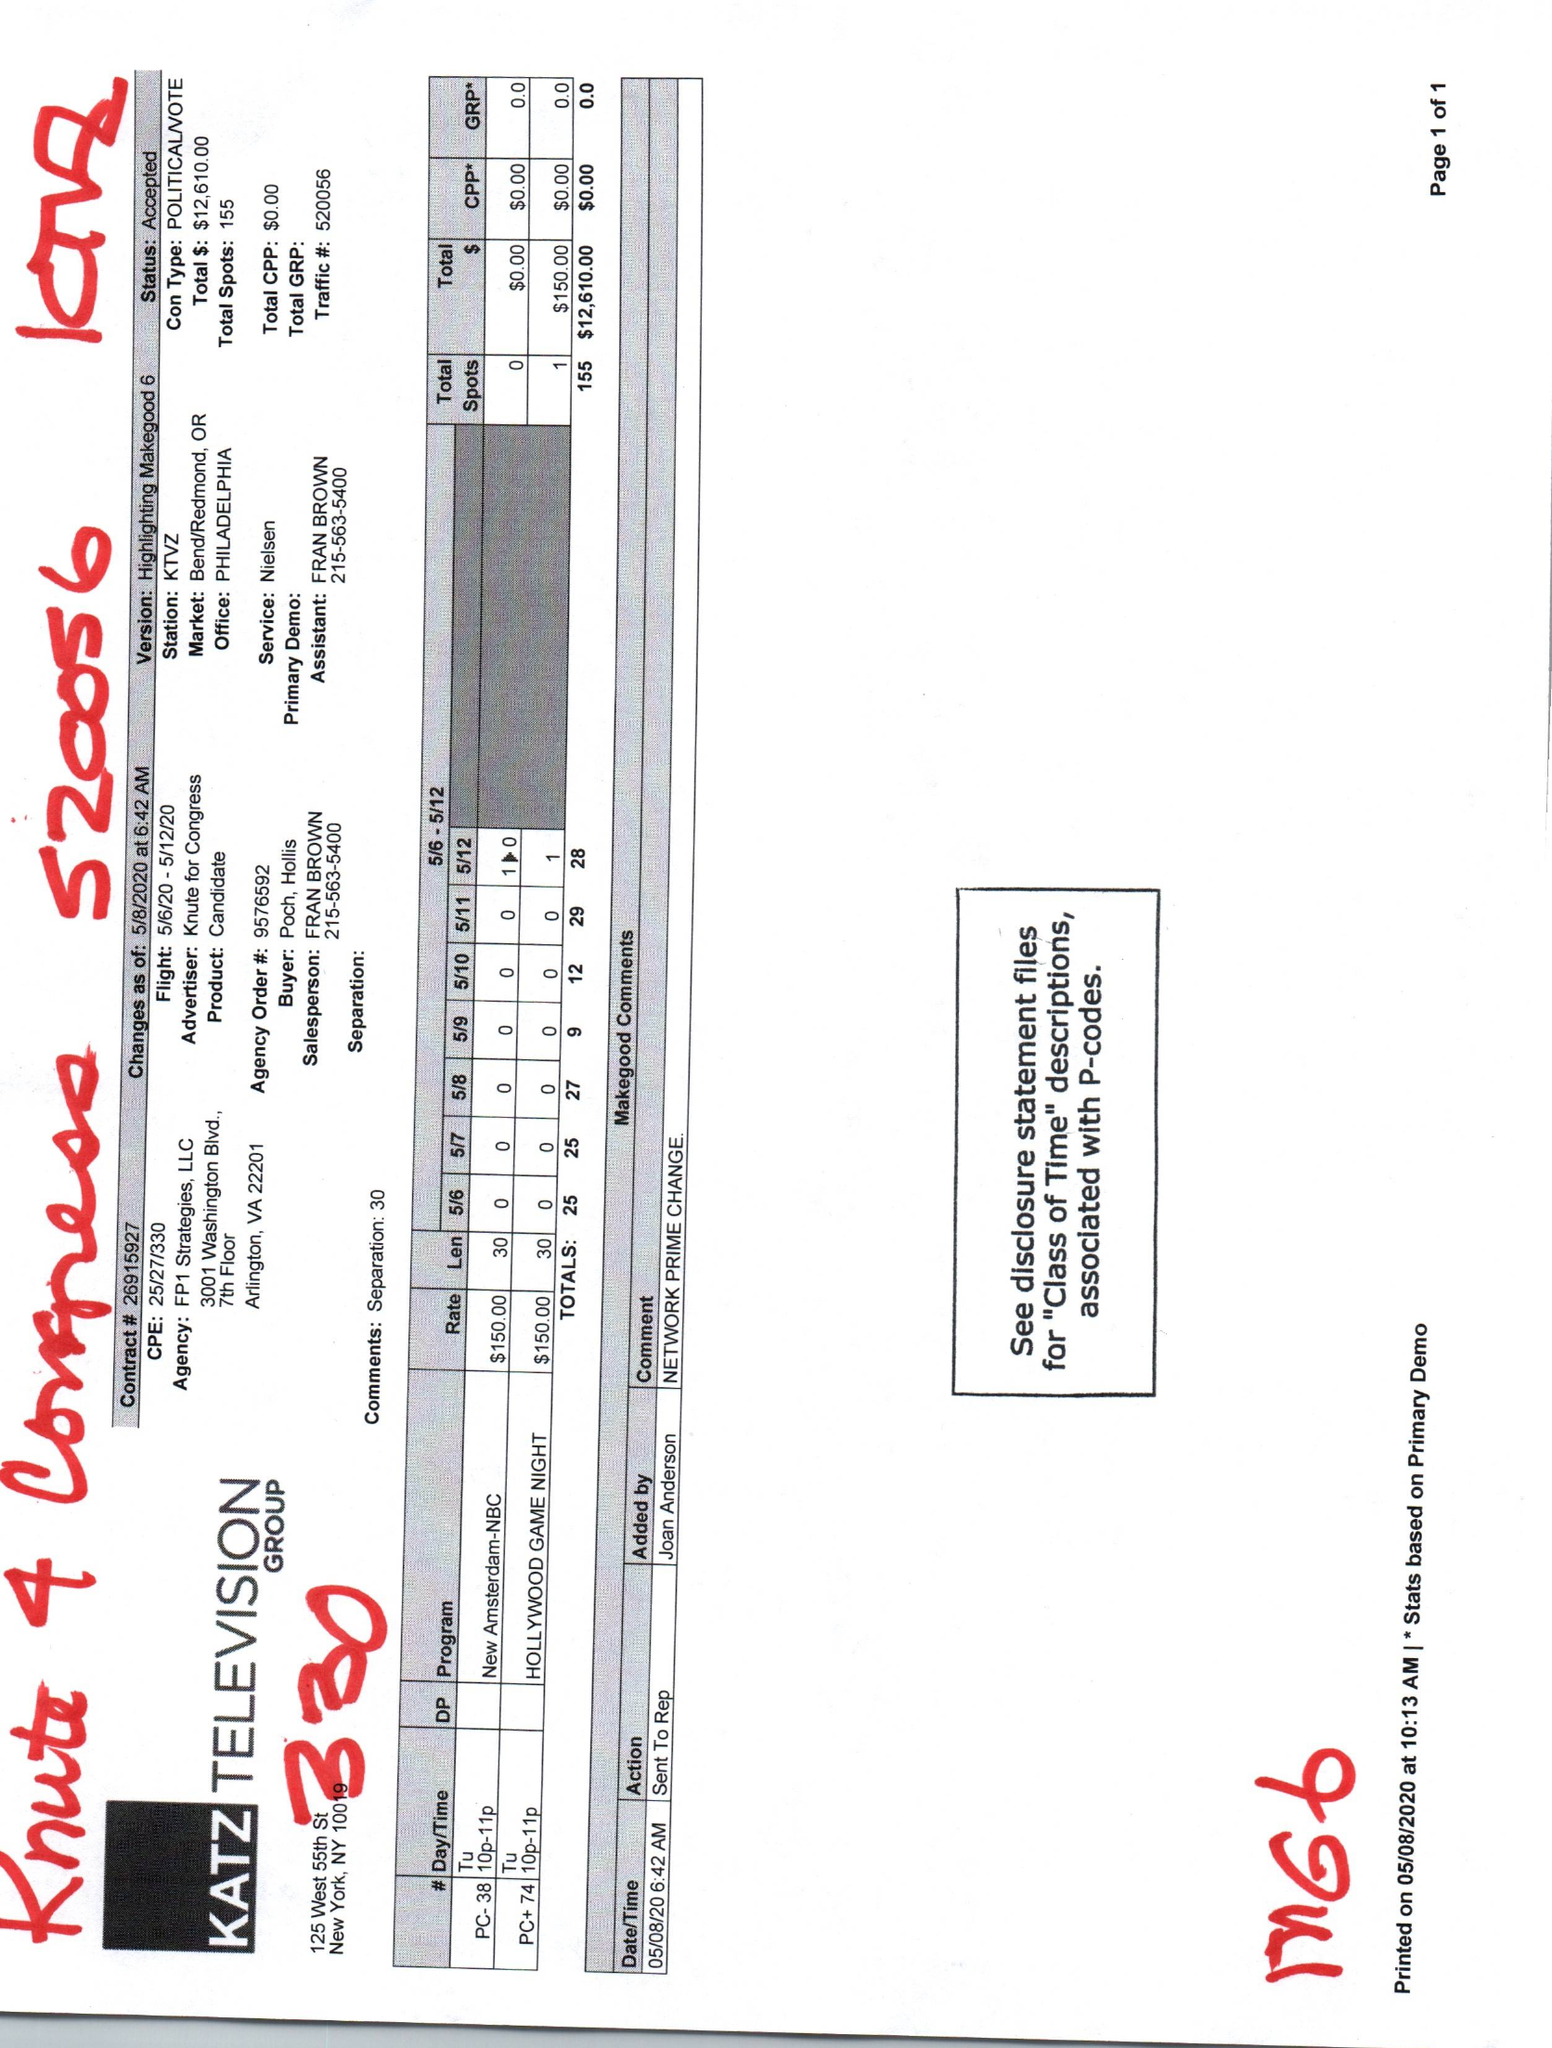What is the value for the flight_from?
Answer the question using a single word or phrase. 05/06/20 